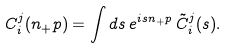<formula> <loc_0><loc_0><loc_500><loc_500>C _ { i } ^ { j } ( n _ { + } p ) = \int d s \, e ^ { i s n _ { + } p } \, \tilde { C } _ { i } ^ { j } ( s ) .</formula> 